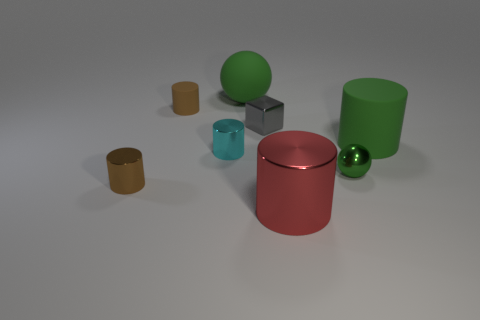Add 2 red blocks. How many objects exist? 10 Subtract all tiny matte cylinders. How many cylinders are left? 4 Subtract all cyan cylinders. How many cylinders are left? 4 Add 2 large green cylinders. How many large green cylinders are left? 3 Add 7 green matte balls. How many green matte balls exist? 8 Subtract 0 gray spheres. How many objects are left? 8 Subtract all cubes. How many objects are left? 7 Subtract all cyan balls. Subtract all red cylinders. How many balls are left? 2 Subtract all green cubes. How many gray cylinders are left? 0 Subtract all big green shiny things. Subtract all large red cylinders. How many objects are left? 7 